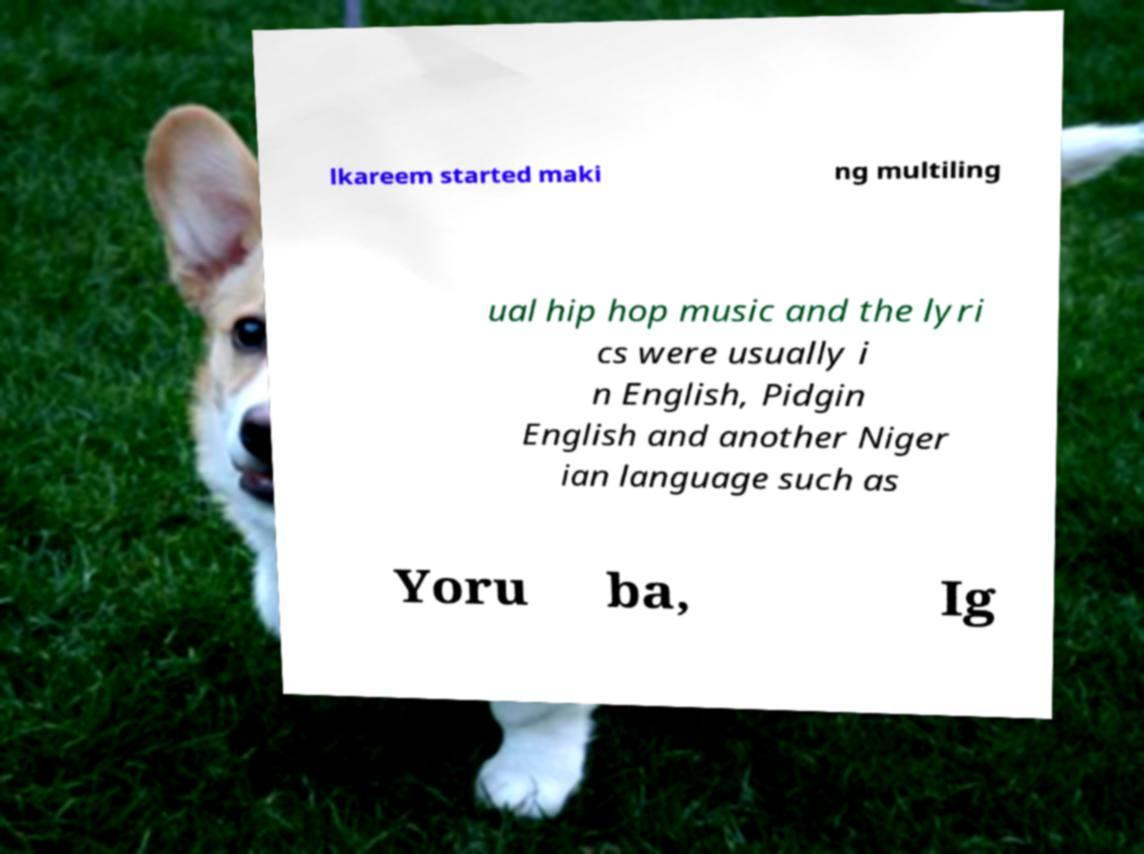Could you extract and type out the text from this image? lkareem started maki ng multiling ual hip hop music and the lyri cs were usually i n English, Pidgin English and another Niger ian language such as Yoru ba, Ig 